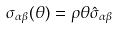<formula> <loc_0><loc_0><loc_500><loc_500>\sigma _ { \alpha \beta } ( \theta ) = \rho \theta \hat { \sigma } _ { \alpha \beta }</formula> 